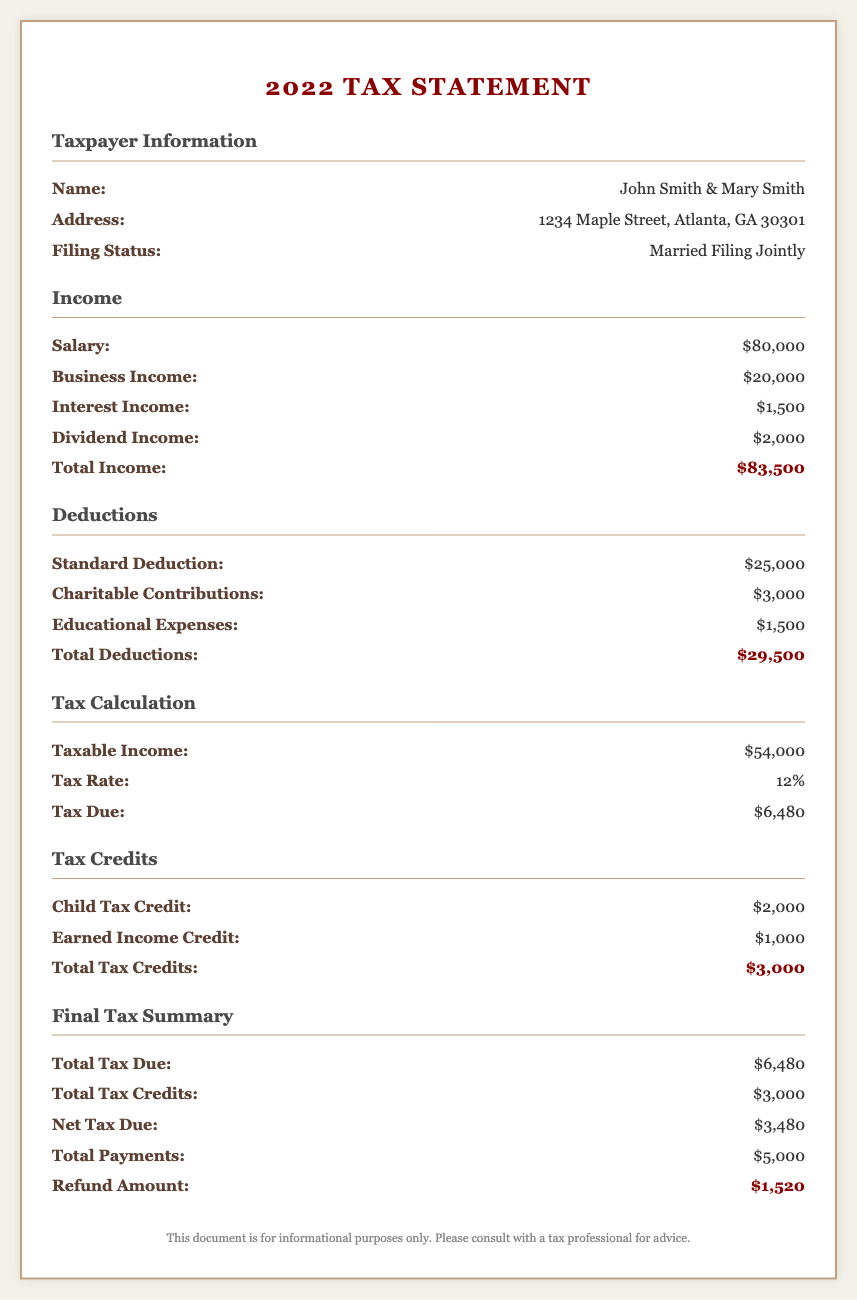What is the total income? The total income is calculated by summing all income sources, including salary, business income, interest income, and dividend income, resulting in $80,000 + $20,000 + $1,500 + $2,000 = $83,500.
Answer: $83,500 What is the total tax due? The total tax due amount is given directly in the document, summarizing the tax calculation after all evaluations.
Answer: $6,480 What is the total deductions amount? The total deductions are computed by adding the standard deduction, charitable contributions, and educational expenses, which equal $25,000 + $3,000 + $1,500 = $29,500.
Answer: $29,500 What is the refund amount? The refund amount is calculated based on the total payments minus the net tax due, which is provided in the document.
Answer: $1,520 What is the filing status of the taxpayers? The filing status is provided in the individual taxpayer information section, identifying how they are filing their taxes.
Answer: Married Filing Jointly What is the taxable income? The taxable income is derived from the total income after deductions are applied, which is shown in the tax calculation section.
Answer: $54,000 What is the percentage tax rate applied? The tax rate is presented in the tax calculation section, indicating the applicable tax rate for the taxable income.
Answer: 12% What types of tax credits are mentioned? The document lists specific tax credits, including the Child Tax Credit and Earned Income Credit, explicitly naming these credits.
Answer: Child Tax Credit, Earned Income Credit What are the total payments made? The total payments made are specified in the final tax summary section, indicating the amount already paid against the tax dues.
Answer: $5,000 